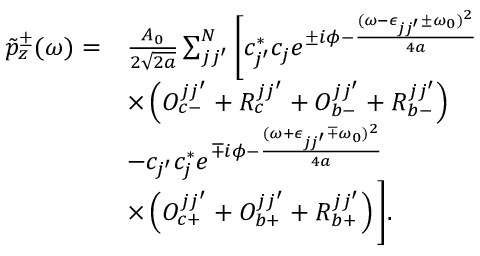<formula> <loc_0><loc_0><loc_500><loc_500>\begin{array} { r l } { \tilde { p } _ { z } ^ { \pm } ( \omega ) = } & { \frac { A _ { 0 } } { 2 \sqrt { 2 a } } \sum _ { j j ^ { \prime } } ^ { N } \left [ c _ { j ^ { \prime } } ^ { * } c _ { j } e ^ { \pm i \phi - \frac { ( \omega - \epsilon _ { j j ^ { \prime } } \pm \omega _ { 0 } ) ^ { 2 } } { 4 a } } } \\ & { \times \left ( O _ { c - } ^ { j j ^ { \prime } } + R _ { c } ^ { j j ^ { \prime } } + O _ { b - } ^ { j j ^ { \prime } } + R _ { b - } ^ { j j ^ { \prime } } \right ) } \\ & { - c _ { j ^ { \prime } } c _ { j } ^ { * } e ^ { \mp i \phi - \frac { ( \omega + \epsilon _ { j j ^ { \prime } } \mp \omega _ { 0 } ) ^ { 2 } } { 4 a } } } \\ & { \times \left ( O _ { c + } ^ { j j ^ { \prime } } + O _ { b + } ^ { j j ^ { \prime } } + R _ { b + } ^ { j j ^ { \prime } } \right ) \right ] . } \end{array}</formula> 